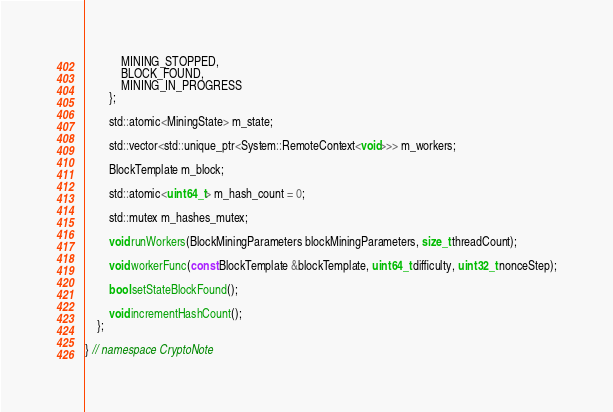Convert code to text. <code><loc_0><loc_0><loc_500><loc_500><_C_>            MINING_STOPPED,
            BLOCK_FOUND,
            MINING_IN_PROGRESS
        };

        std::atomic<MiningState> m_state;

        std::vector<std::unique_ptr<System::RemoteContext<void>>> m_workers;

        BlockTemplate m_block;

        std::atomic<uint64_t> m_hash_count = 0;

        std::mutex m_hashes_mutex;

        void runWorkers(BlockMiningParameters blockMiningParameters, size_t threadCount);

        void workerFunc(const BlockTemplate &blockTemplate, uint64_t difficulty, uint32_t nonceStep);

        bool setStateBlockFound();

        void incrementHashCount();
    };

} // namespace CryptoNote
</code> 